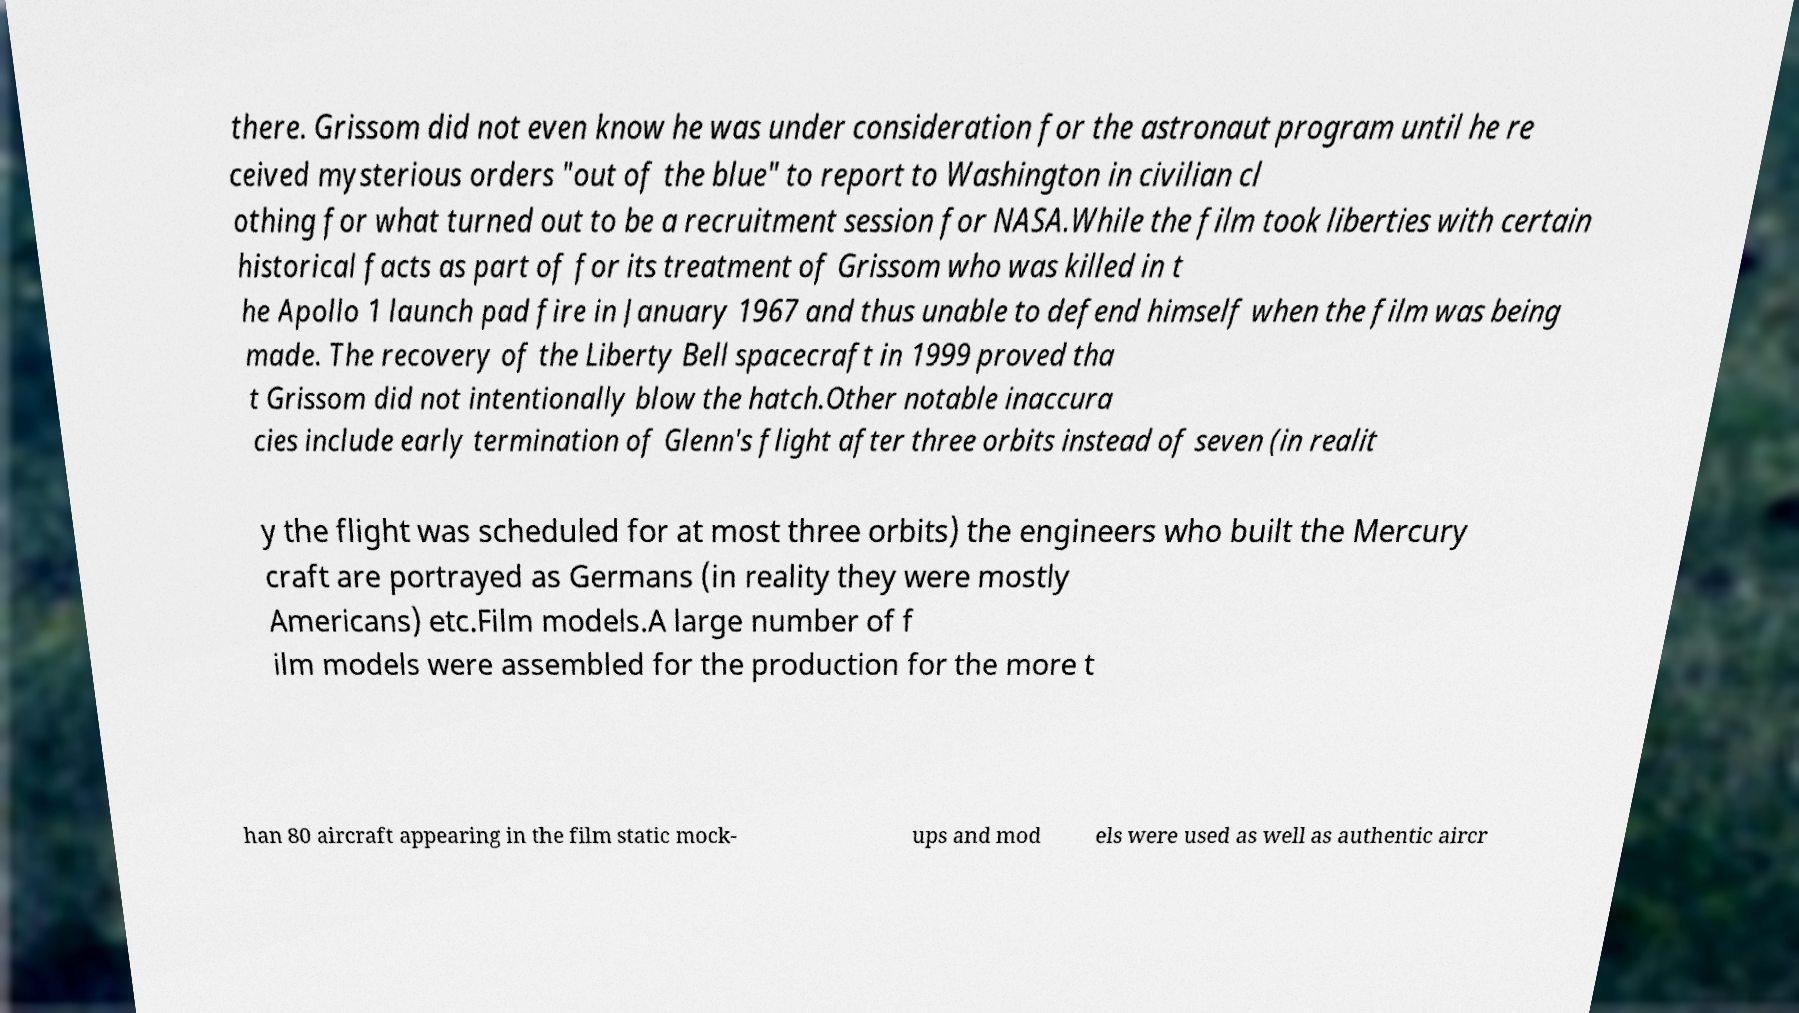There's text embedded in this image that I need extracted. Can you transcribe it verbatim? there. Grissom did not even know he was under consideration for the astronaut program until he re ceived mysterious orders "out of the blue" to report to Washington in civilian cl othing for what turned out to be a recruitment session for NASA.While the film took liberties with certain historical facts as part of for its treatment of Grissom who was killed in t he Apollo 1 launch pad fire in January 1967 and thus unable to defend himself when the film was being made. The recovery of the Liberty Bell spacecraft in 1999 proved tha t Grissom did not intentionally blow the hatch.Other notable inaccura cies include early termination of Glenn's flight after three orbits instead of seven (in realit y the flight was scheduled for at most three orbits) the engineers who built the Mercury craft are portrayed as Germans (in reality they were mostly Americans) etc.Film models.A large number of f ilm models were assembled for the production for the more t han 80 aircraft appearing in the film static mock- ups and mod els were used as well as authentic aircr 